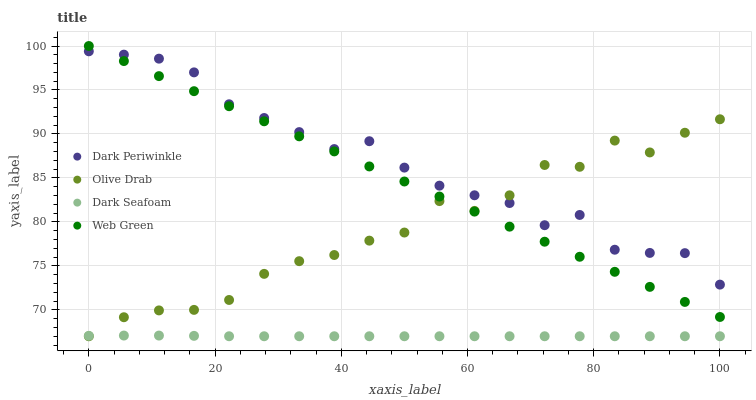Does Dark Seafoam have the minimum area under the curve?
Answer yes or no. Yes. Does Dark Periwinkle have the maximum area under the curve?
Answer yes or no. Yes. Does Web Green have the minimum area under the curve?
Answer yes or no. No. Does Web Green have the maximum area under the curve?
Answer yes or no. No. Is Web Green the smoothest?
Answer yes or no. Yes. Is Olive Drab the roughest?
Answer yes or no. Yes. Is Dark Periwinkle the smoothest?
Answer yes or no. No. Is Dark Periwinkle the roughest?
Answer yes or no. No. Does Dark Seafoam have the lowest value?
Answer yes or no. Yes. Does Web Green have the lowest value?
Answer yes or no. No. Does Web Green have the highest value?
Answer yes or no. Yes. Does Dark Periwinkle have the highest value?
Answer yes or no. No. Is Dark Seafoam less than Web Green?
Answer yes or no. Yes. Is Dark Periwinkle greater than Dark Seafoam?
Answer yes or no. Yes. Does Web Green intersect Dark Periwinkle?
Answer yes or no. Yes. Is Web Green less than Dark Periwinkle?
Answer yes or no. No. Is Web Green greater than Dark Periwinkle?
Answer yes or no. No. Does Dark Seafoam intersect Web Green?
Answer yes or no. No. 